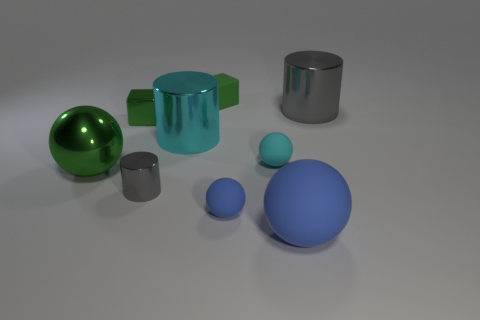What number of large spheres are there?
Offer a very short reply. 2. Does the tiny cylinder have the same material as the large sphere that is on the left side of the shiny block?
Ensure brevity in your answer.  Yes. There is a large ball right of the cyan sphere; does it have the same color as the small cylinder?
Provide a short and direct response. No. What material is the big object that is in front of the big cyan cylinder and to the right of the green sphere?
Provide a succinct answer. Rubber. What is the size of the metal block?
Your answer should be very brief. Small. There is a rubber block; does it have the same color as the shiny cylinder that is in front of the large green shiny thing?
Make the answer very short. No. How many other things are there of the same color as the large rubber sphere?
Make the answer very short. 1. Do the shiny cylinder behind the large cyan thing and the blue rubber sphere to the right of the small blue object have the same size?
Provide a succinct answer. Yes. There is a large cylinder on the right side of the big cyan cylinder; what is its color?
Make the answer very short. Gray. Is the number of gray things behind the green rubber object less than the number of red spheres?
Make the answer very short. No. 